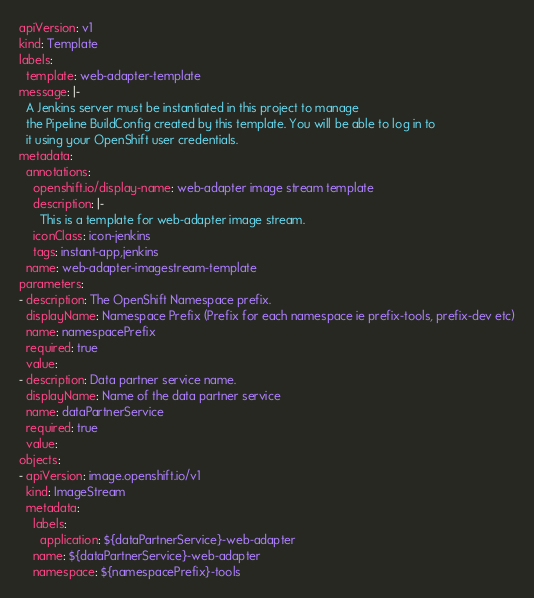Convert code to text. <code><loc_0><loc_0><loc_500><loc_500><_YAML_>apiVersion: v1
kind: Template
labels:
  template: web-adapter-template
message: |-
  A Jenkins server must be instantiated in this project to manage
  the Pipeline BuildConfig created by this template. You will be able to log in to
  it using your OpenShift user credentials.
metadata:
  annotations:
    openshift.io/display-name: web-adapter image stream template
    description: |-
      This is a template for web-adapter image stream.
    iconClass: icon-jenkins
    tags: instant-app,jenkins
  name: web-adapter-imagestream-template
parameters:
- description: The OpenShift Namespace prefix.
  displayName: Namespace Prefix (Prefix for each namespace ie prefix-tools, prefix-dev etc)
  name: namespacePrefix
  required: true
  value:
- description: Data partner service name.
  displayName: Name of the data partner service
  name: dataPartnerService
  required: true
  value:
objects:
- apiVersion: image.openshift.io/v1
  kind: ImageStream
  metadata:
    labels:
      application: ${dataPartnerService}-web-adapter
    name: ${dataPartnerService}-web-adapter
    namespace: ${namespacePrefix}-tools</code> 